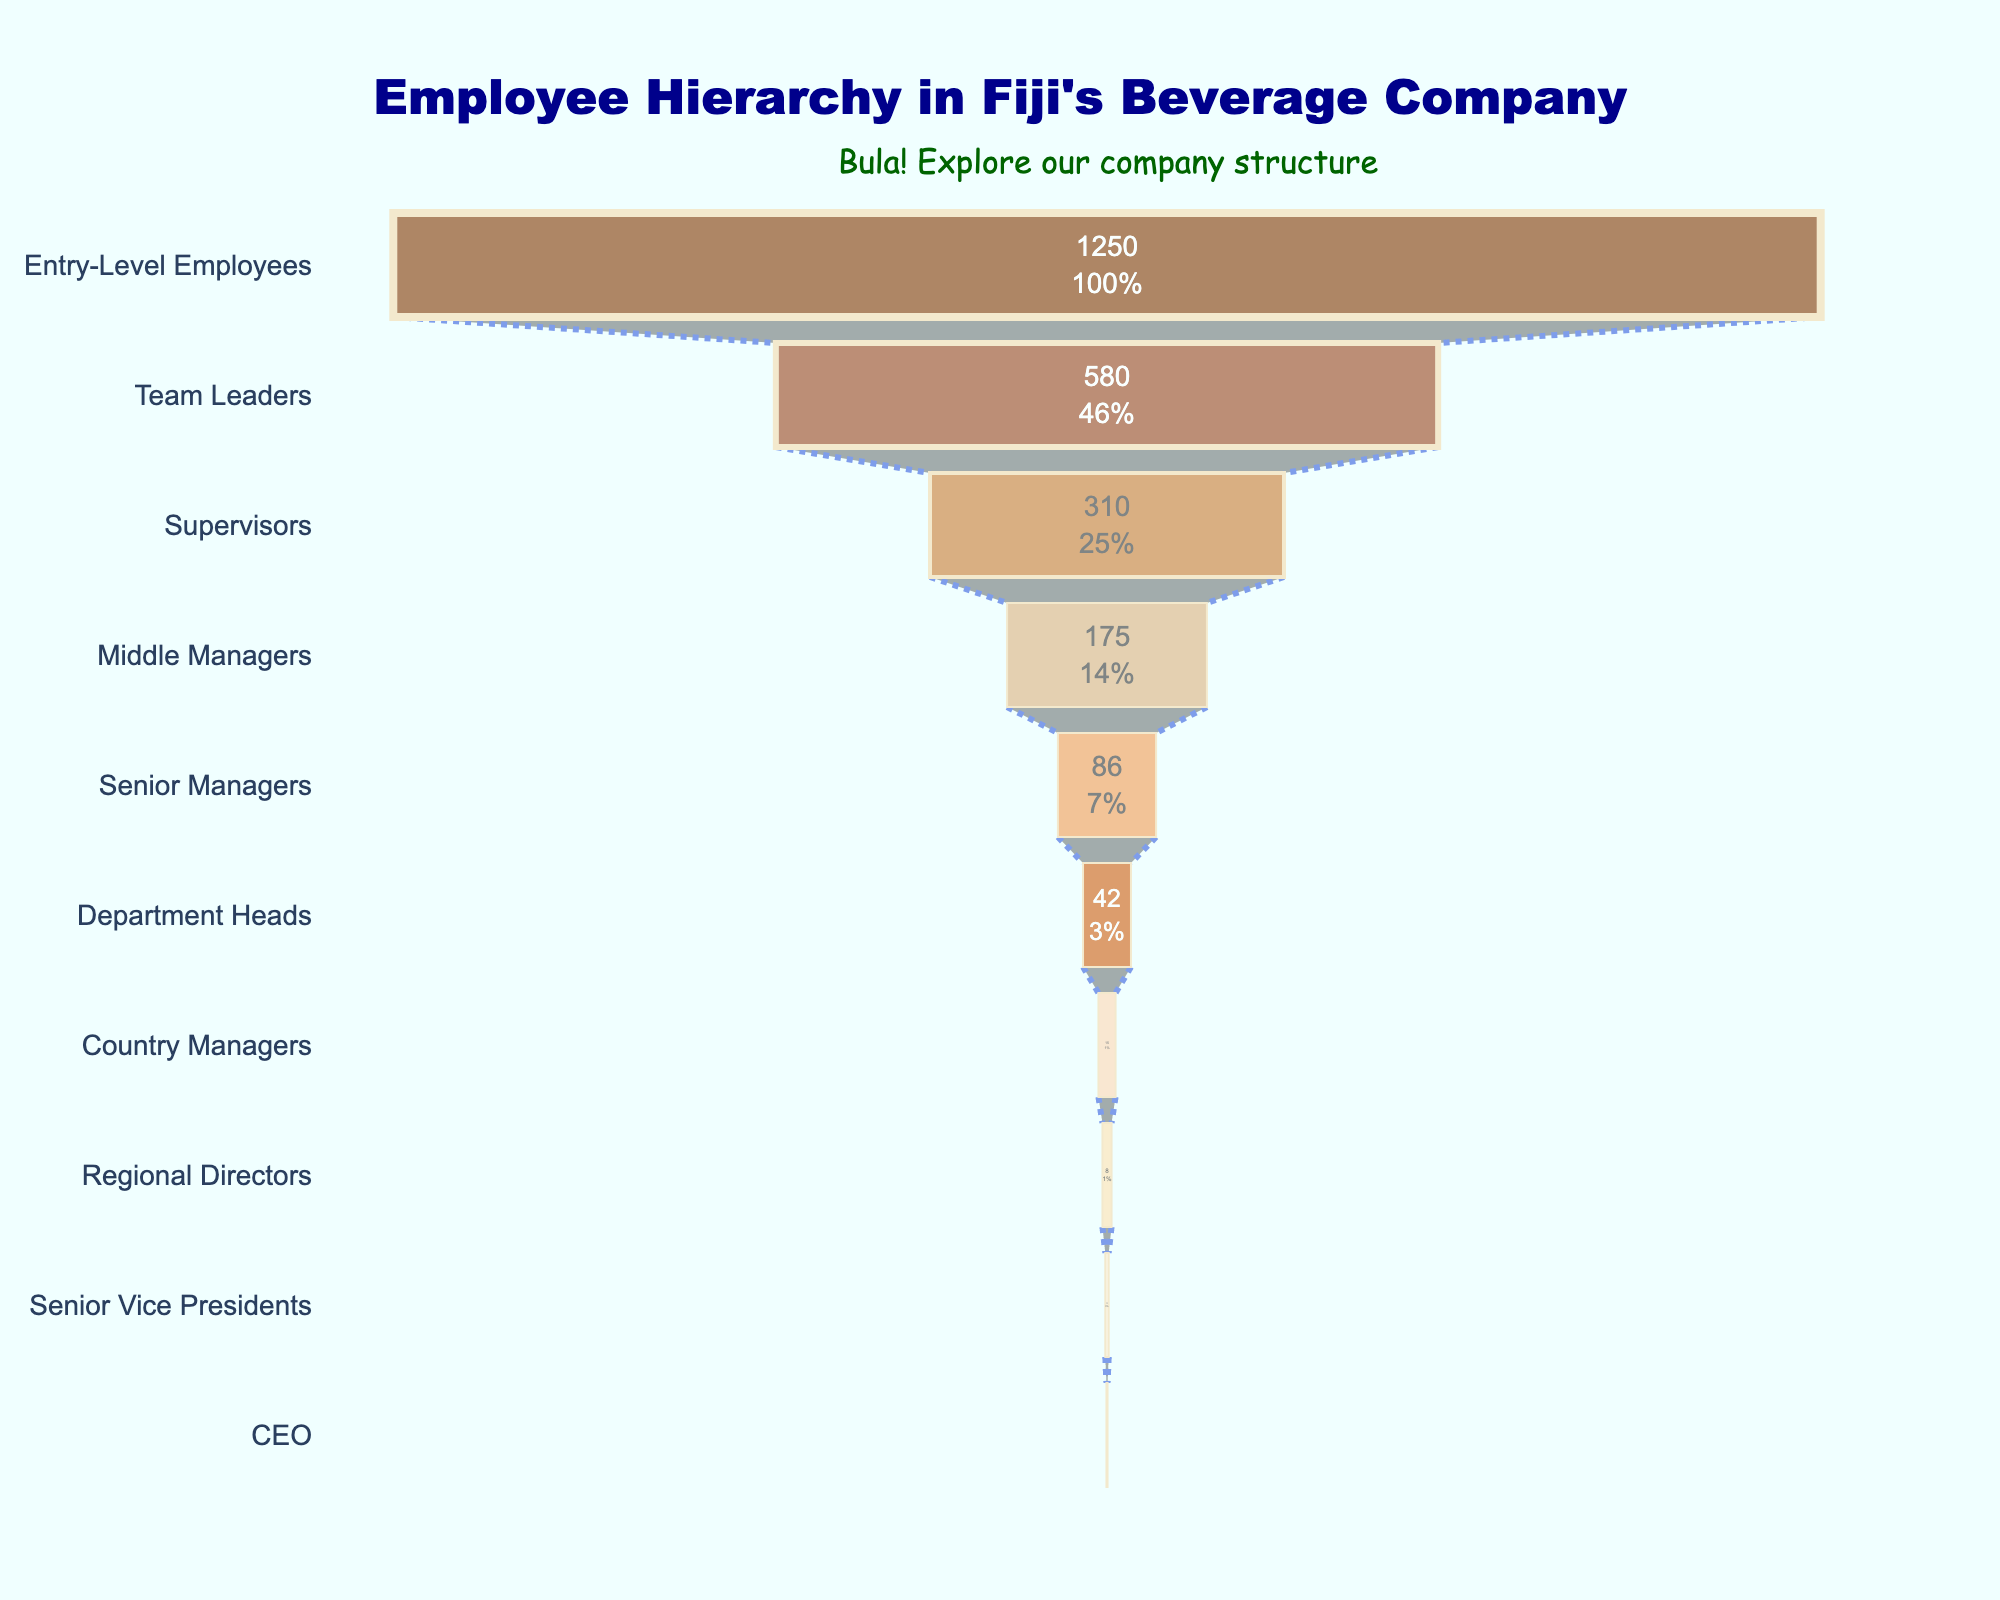what's the title of the figure? The title is usually located at the top of the figure and summarizes its content. In this case, it reads "Employee Hierarchy in Fiji's Beverage Company" which is clear from the layout instructions.
Answer: Employee Hierarchy in Fiji's Beverage Company What's the color of the bar representing the 'Team Leaders' position? The colors are listed in the code and there are specific markers for each position. The 'Team Leaders' has the color "#FFE4B5".
Answer: Light Yellow How many people hold the 'Senior Vice Presidents' title? The figure lists the number of employees for each position. By looking directly at the respective bar for 'Senior Vice Presidents', you can read the number off the chart.
Answer: 3 What percentage of total employees are 'Entry-Level Employees'? The funnel chart uses 'percent initial' text info, showing the percentage of each position relative to the total employees. The 'Entry-Level Employees' bar should display this value.
Answer: 45.73% Which position has the least number of employees? The figure shows the employee count for each position. The position with the smallest bar represents the least number of employees. In this case, it is the 'CEO'.
Answer: CEO Compare the number of 'Country Managers' to 'Regional Directors'. Which group is larger and by how much? Compare the numbers for both positions by looking at their respective bars. 'Country Managers' have 15 and 'Regional Directors' have 8. Subtract to find the difference.
Answer: Country Managers, by 7 If you add the employees of 'Supervisors' and 'Middle Managers', what is the result? Sum the number of employees for 'Supervisors' (310) and 'Middle Managers' (175). 310 + 175 = 485.
Answer: 485 What is the cumulative number of employees from 'Senior Managers' down to 'CEO'? Add up the number of employees from 'Senior Managers' (86), 'Department Heads' (42), 'Country Managers' (15), 'Regional Directors' (8), 'Senior Vice Presidents' (3), and 'CEO' (1) for the cumulative total: 86 + 42 + 15 + 8 + 3 + 1 = 155.
Answer: 155 What is the difference in the number of employees between 'Supervisors' and 'Team Leaders'? Subtract the number of employees in 'Supervisors' (310) from 'Team Leaders' (580). 580 - 310 = 270.
Answer: 270 